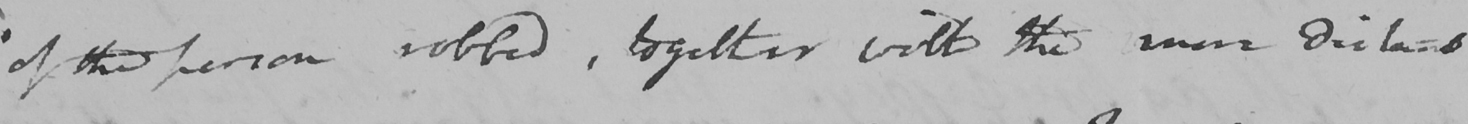Can you read and transcribe this handwriting? of the person robbed , together with the more distant 